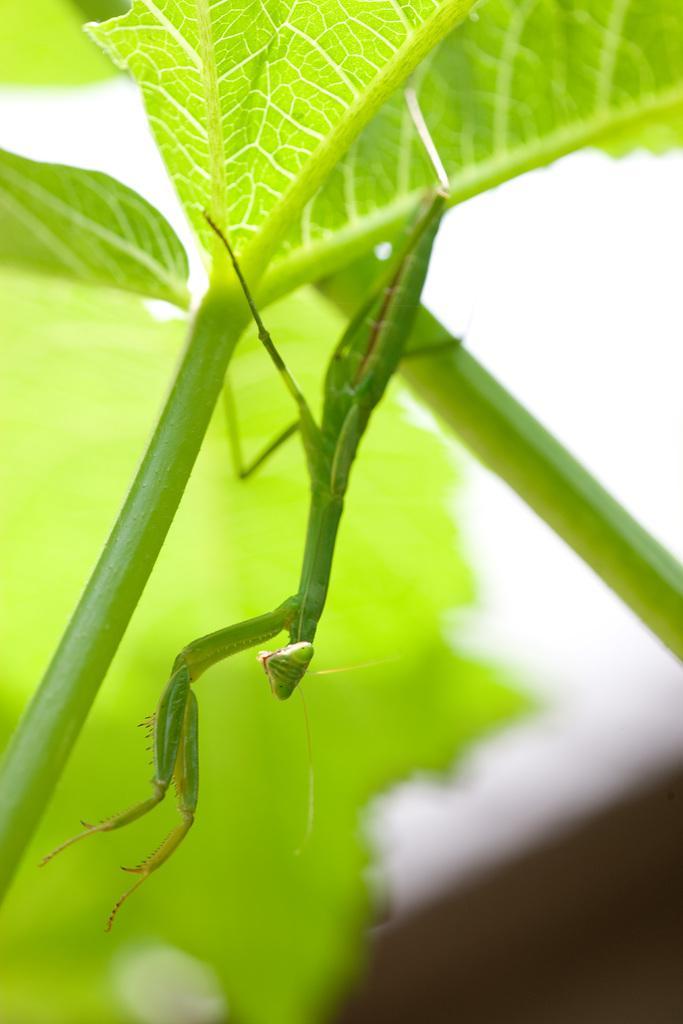Could you give a brief overview of what you see in this image? In this image we can see an insect on a leaf. In the background the image is blur but we can see a leaf and an object. 